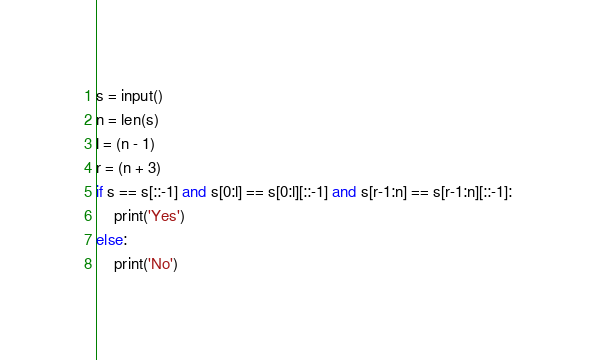Convert code to text. <code><loc_0><loc_0><loc_500><loc_500><_Python_>s = input()
n = len(s)
l = (n - 1)
r = (n + 3)
if s == s[::-1] and s[0:l] == s[0:l][::-1] and s[r-1:n] == s[r-1:n][::-1]:
    print('Yes')
else:
    print('No')</code> 